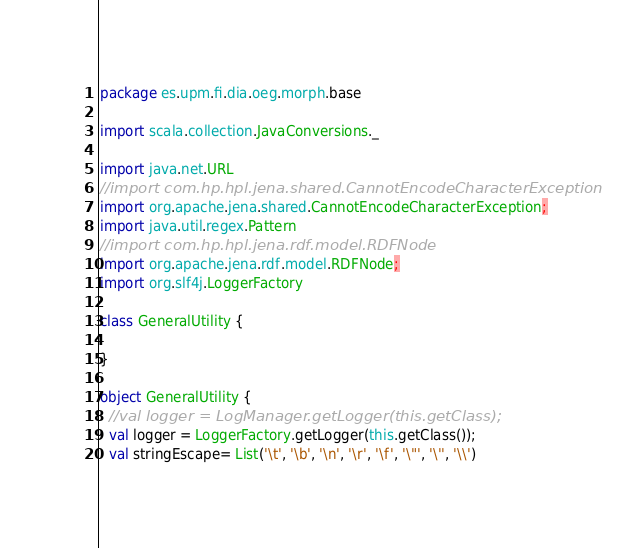Convert code to text. <code><loc_0><loc_0><loc_500><loc_500><_Scala_>package es.upm.fi.dia.oeg.morph.base

import scala.collection.JavaConversions._

import java.net.URL
//import com.hp.hpl.jena.shared.CannotEncodeCharacterException
import org.apache.jena.shared.CannotEncodeCharacterException;
import java.util.regex.Pattern
//import com.hp.hpl.jena.rdf.model.RDFNode
import org.apache.jena.rdf.model.RDFNode;
import org.slf4j.LoggerFactory

class GeneralUtility {

}

object GeneralUtility {
  //val logger = LogManager.getLogger(this.getClass);
  val logger = LoggerFactory.getLogger(this.getClass());
  val stringEscape= List('\t', '\b', '\n', '\r', '\f', '\"', '\'', '\\')
</code> 